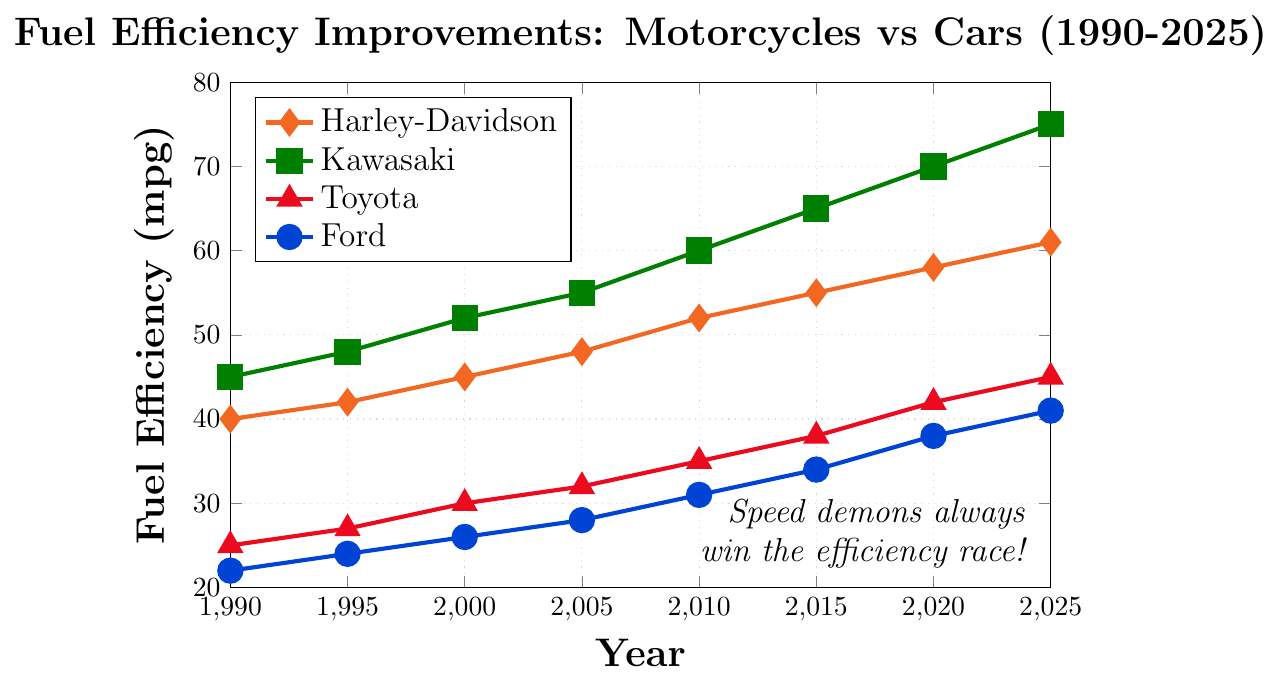Which vehicle shows the most improvement in fuel efficiency between 1990 and 2025? To determine this, we need to calculate the difference between the 2025 and 1990 values for each vehicle: Harley-Davidson (61-40 = 21), Kawasaki (75-45 = 30), Toyota (45-25 = 20), Ford (41-22 = 19). Kawasaki shows the highest improvement with 30 mpg.
Answer: Kawasaki How does the 2010 fuel efficiency of Harley-Davidson compare to that of Toyota? From the chart, the 2010 fuel efficiency for Harley-Davidson is 52 mpg, while for Toyota it is 35 mpg. Harley-Davidson is more fuel-efficient.
Answer: Harley-Davidson is more fuel-efficient What's the average fuel efficiency of Ford Cars from 1990 to 2025? The fuel efficiency values for Ford Cars from 1990 to 2025 are: 22, 24, 26, 28, 31, 34, 38, 41. To find the average, we sum these values: 22+24+26+28+31+34+38+41 = 244, then divide by the number of years (8): 244/8 = 30.5 mpg.
Answer: 30.5 mpg In which year did both Harley-Davidson and Kawasaki have the same rate of increase in fuel efficiency compared to the previous five-year period? Observing the chart, in 1995 both Harley-Davidson and Kawasaki increase by 2 mpg from 1990 to 1995 (40 to 42 and 45 to 48, respectively).
Answer: 1995 Name the vehicle that had the lowest fuel efficiency in 2005 and specify its value. From the chart, the vehicle with the lowest fuel efficiency in 2005 is Ford at 28 mpg.
Answer: Ford, 28 mpg Compare the rate of increase in fuel efficiency for Toyota Cars from 2000 to 2020. Was it constant across the periods? Toyota Cars have an increase of 3 mpg from 2000 to 2005 (30 to 32), 3 mpg from 2005 to 2010 (32 to 35), 3 mpg from 2010 to 2015 (35 to 38), and 4 mpg from 2015 to 2020 (38 to 42). The rate increases slightly from 2015 to 2020 compared to previous periods.
Answer: No, it was not constant What is the trend for Kawasaki Motorcycles' fuel efficiency from 1990 to 2025? Observing the chart, we see a consistent increase in fuel efficiency for Kawasaki Motorcycles from 45 mpg in 1990 to 75 mpg in 2025.
Answer: Consistent increase Which vehicle almost reaches 60 mpg in 2020, and how close is it to reaching 60 mpg? In 2020, Harley-Davidson Motorcycles have a fuel efficiency of 58 mpg, which is 2 mpg shy of 60 mpg.
Answer: Harley-Davidson, 2 mpg shy 